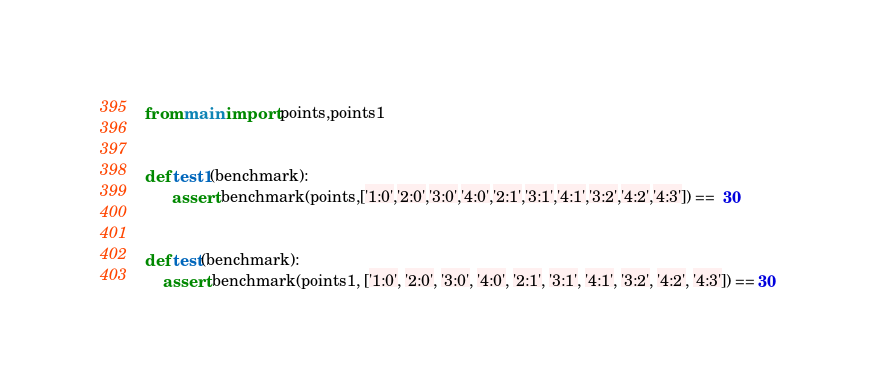<code> <loc_0><loc_0><loc_500><loc_500><_Python_>from main import points,points1


def test1(benchmark):
      assert benchmark(points,['1:0','2:0','3:0','4:0','2:1','3:1','4:1','3:2','4:2','4:3']) ==  30


def test(benchmark):
    assert benchmark(points1, ['1:0', '2:0', '3:0', '4:0', '2:1', '3:1', '4:1', '3:2', '4:2', '4:3']) == 30</code> 